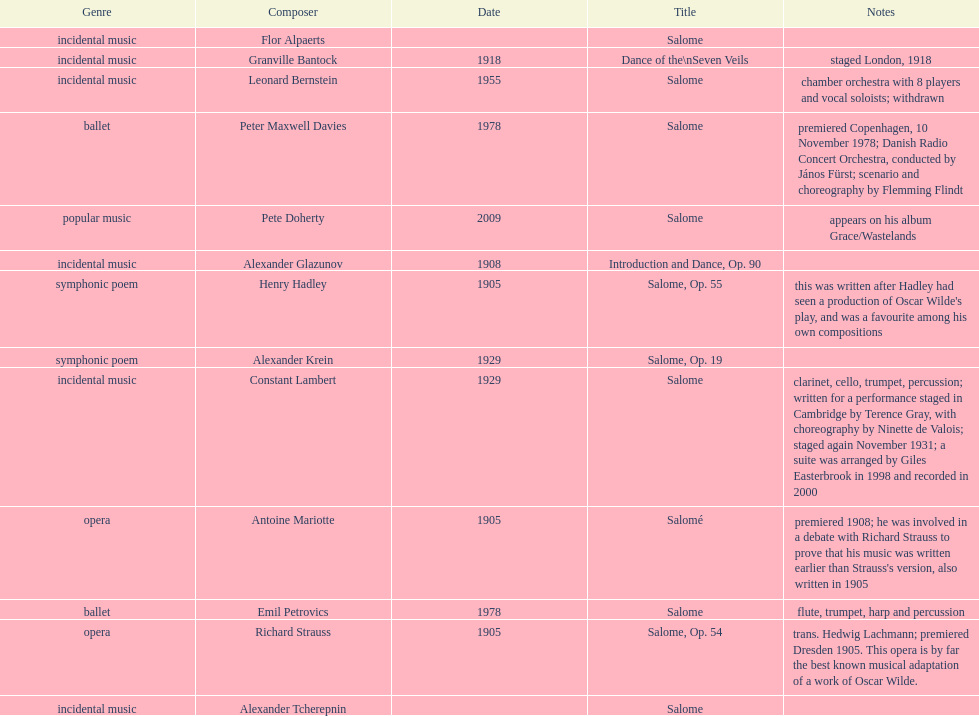Why type of genre was peter maxwell davies' work that was the same as emil petrovics' Ballet. 